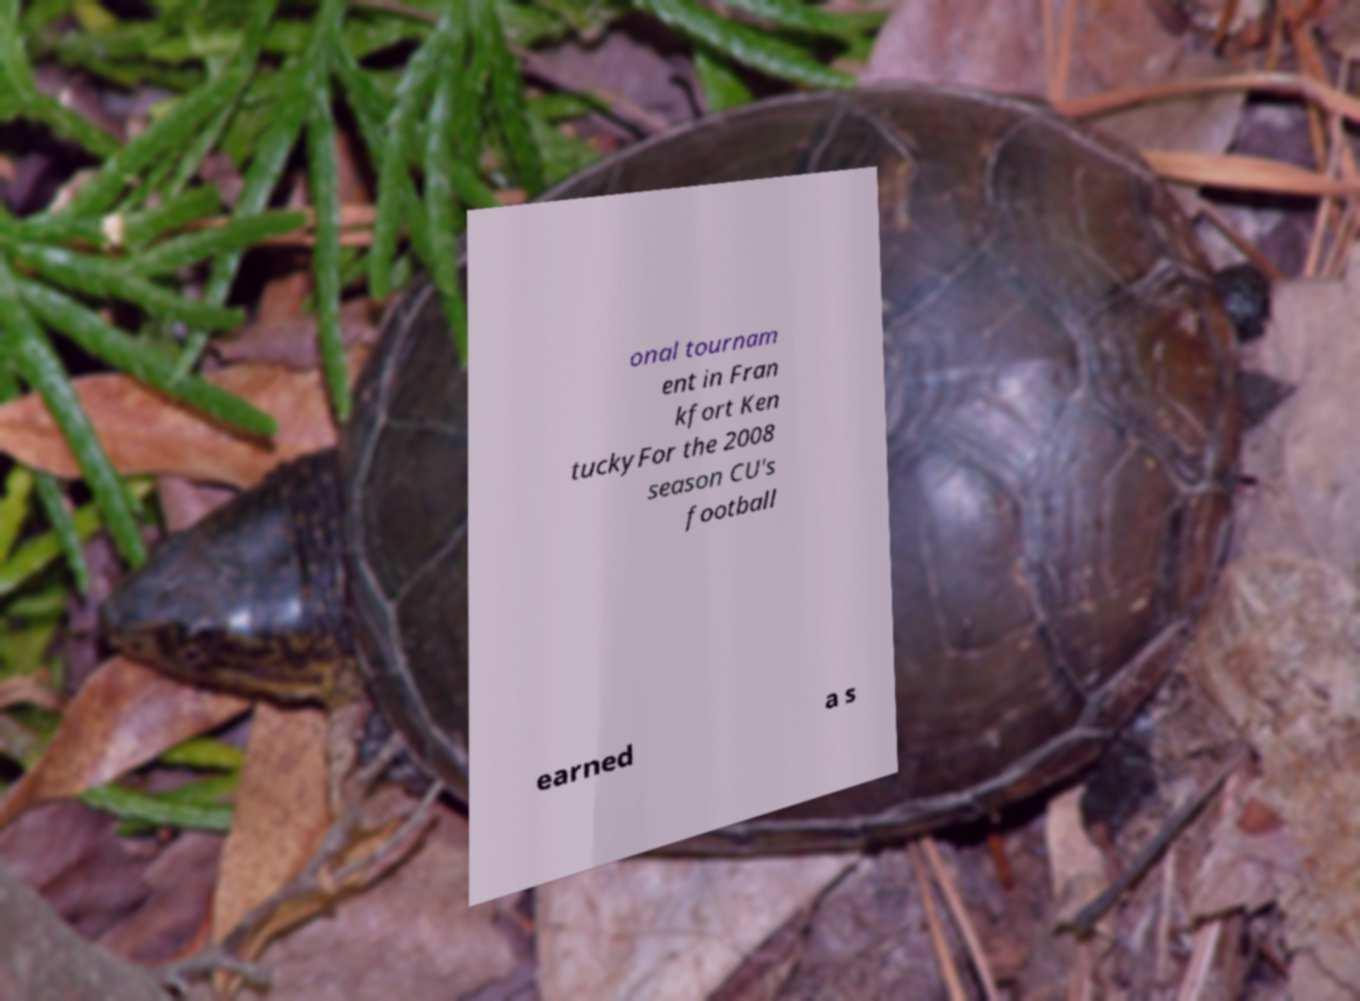Please read and relay the text visible in this image. What does it say? onal tournam ent in Fran kfort Ken tuckyFor the 2008 season CU's football earned a s 